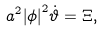Convert formula to latex. <formula><loc_0><loc_0><loc_500><loc_500>a ^ { 2 } { \left | \phi \right | } ^ { 2 } \dot { \vartheta } = \Xi ,</formula> 